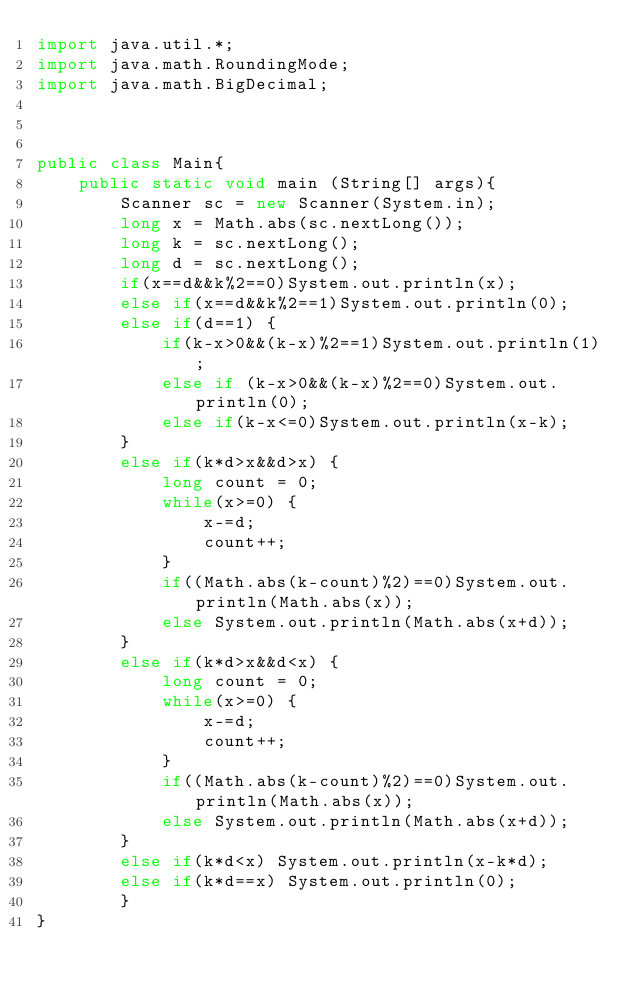<code> <loc_0><loc_0><loc_500><loc_500><_Java_>import java.util.*;
import java.math.RoundingMode;
import java.math.BigDecimal;
 
 
 
public class Main{
	public static void main (String[] args){
		Scanner sc = new Scanner(System.in);
		long x = Math.abs(sc.nextLong());
		long k = sc.nextLong();
		long d = sc.nextLong();
		if(x==d&&k%2==0)System.out.println(x);
		else if(x==d&&k%2==1)System.out.println(0);
		else if(d==1) {
			if(k-x>0&&(k-x)%2==1)System.out.println(1);
			else if (k-x>0&&(k-x)%2==0)System.out.println(0);
			else if(k-x<=0)System.out.println(x-k);
		}
		else if(k*d>x&&d>x) {
			long count = 0;
			while(x>=0) {
				x-=d;
				count++;
			}
			if((Math.abs(k-count)%2)==0)System.out.println(Math.abs(x));
			else System.out.println(Math.abs(x+d));
		}
		else if(k*d>x&&d<x) {
			long count = 0;
			while(x>=0) {
				x-=d;
				count++;
			}
			if((Math.abs(k-count)%2)==0)System.out.println(Math.abs(x));
			else System.out.println(Math.abs(x+d));
		}
		else if(k*d<x) System.out.println(x-k*d);
		else if(k*d==x) System.out.println(0);
		}
}</code> 